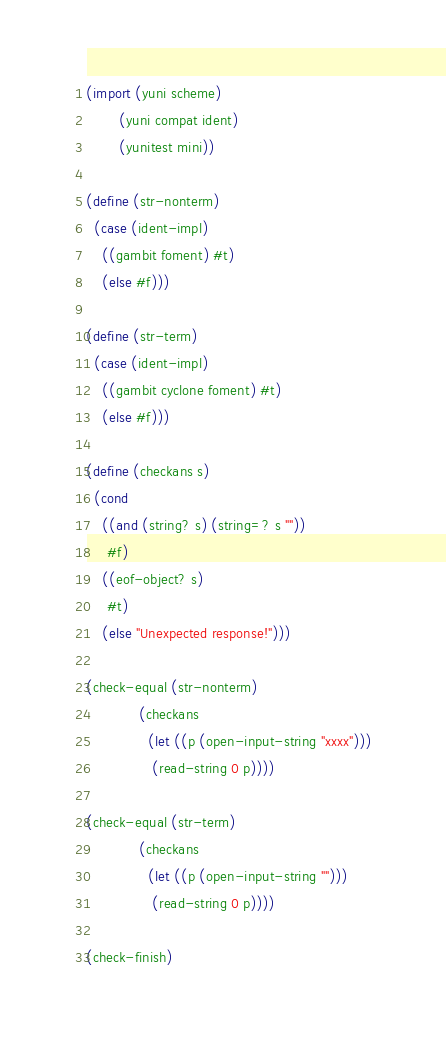<code> <loc_0><loc_0><loc_500><loc_500><_Scheme_>(import (yuni scheme)
        (yuni compat ident)
        (yunitest mini))

(define (str-nonterm) 
  (case (ident-impl)
    ((gambit foment) #t)
    (else #f)))

(define (str-term) 
  (case (ident-impl)
    ((gambit cyclone foment) #t)
    (else #f)))

(define (checkans s)
  (cond
    ((and (string? s) (string=? s ""))
     #f)
    ((eof-object? s)
     #t)
    (else "Unexpected response!")))

(check-equal (str-nonterm)
             (checkans
               (let ((p (open-input-string "xxxx")))
                (read-string 0 p))))

(check-equal (str-term)
             (checkans
               (let ((p (open-input-string "")))
                (read-string 0 p))))

(check-finish)
</code> 